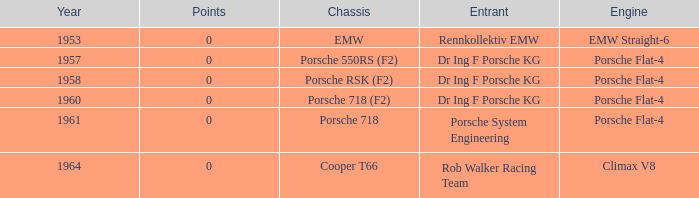Which year had more than 0 points? 0.0. 